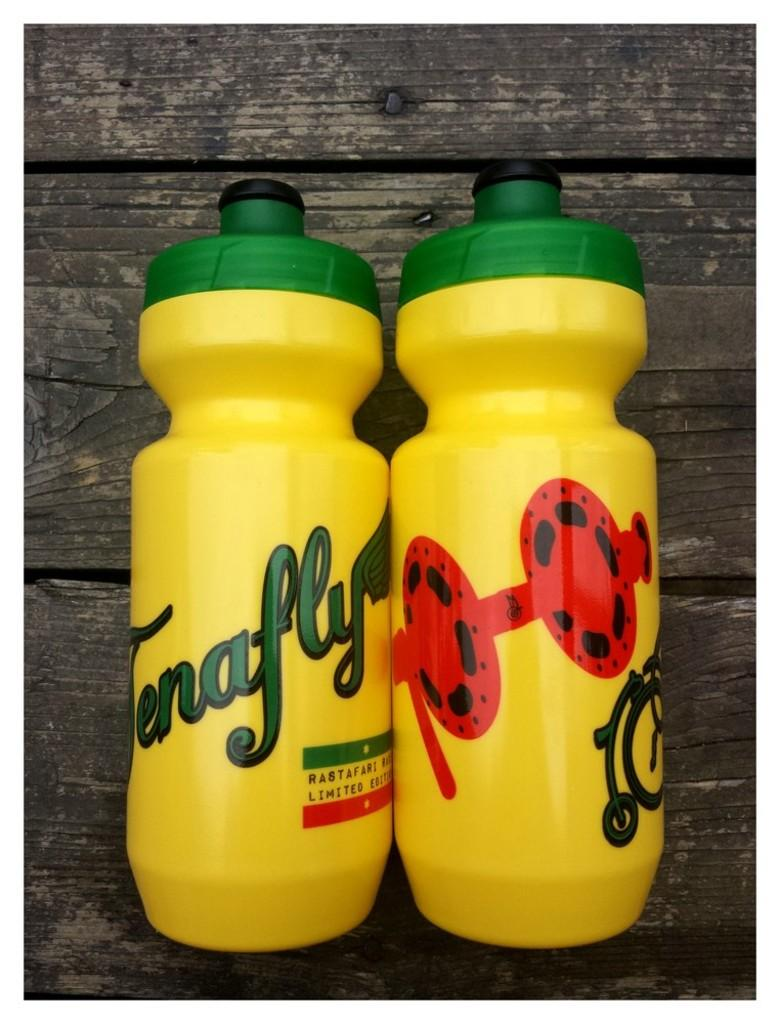<image>
Give a short and clear explanation of the subsequent image. A yellow bottle that says Tenafly is next to another yellow bottle. 